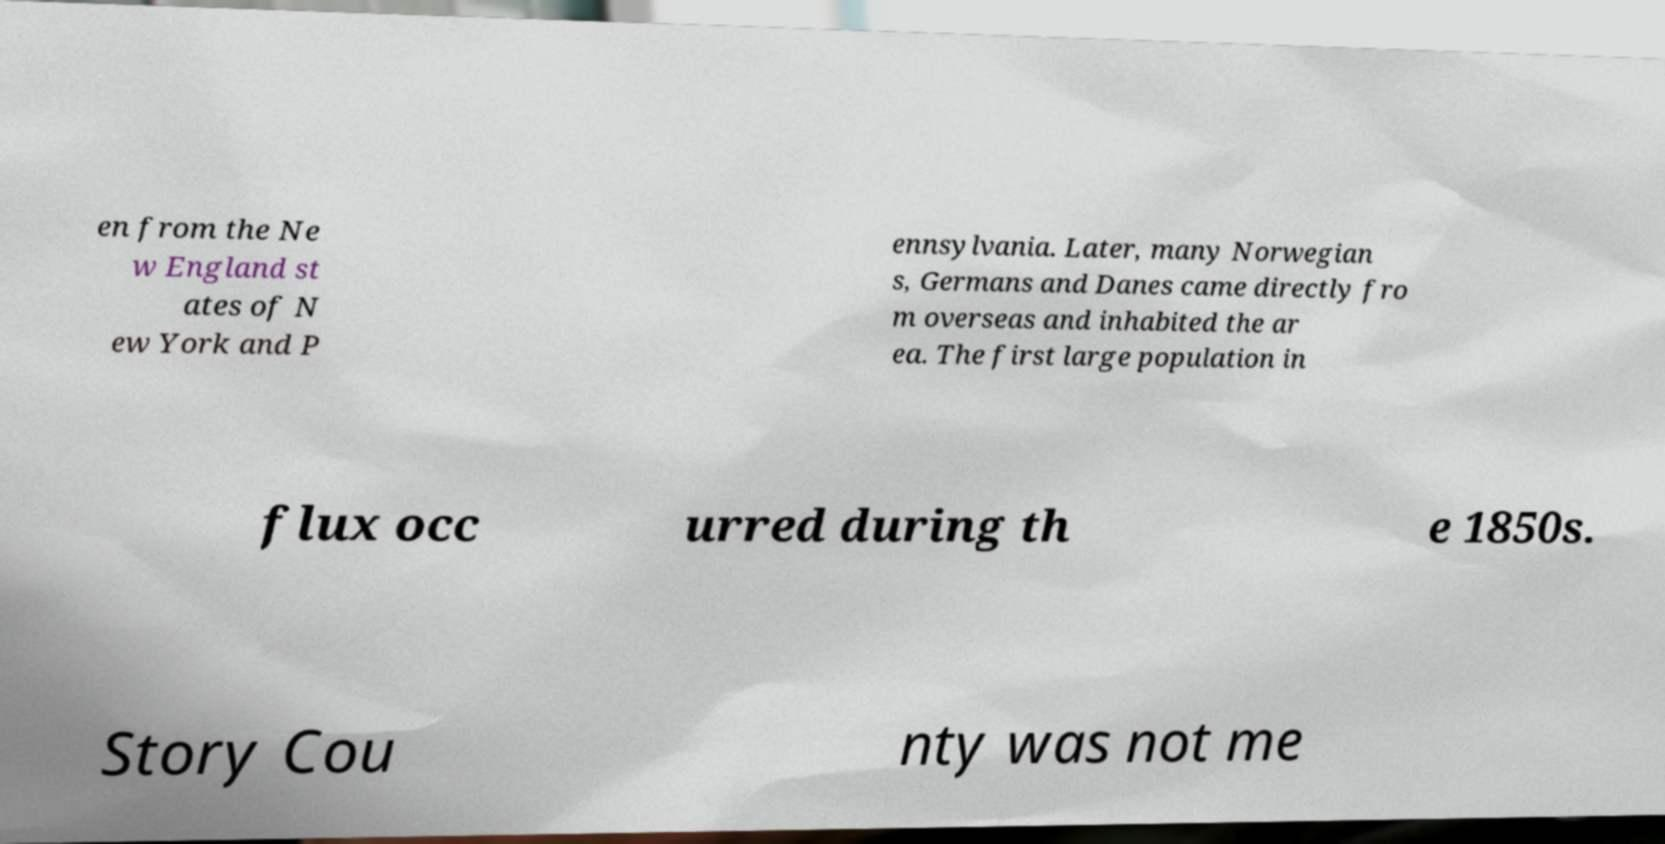Can you read and provide the text displayed in the image?This photo seems to have some interesting text. Can you extract and type it out for me? en from the Ne w England st ates of N ew York and P ennsylvania. Later, many Norwegian s, Germans and Danes came directly fro m overseas and inhabited the ar ea. The first large population in flux occ urred during th e 1850s. Story Cou nty was not me 